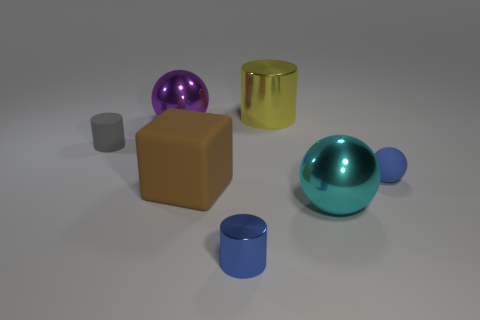What number of other things are there of the same size as the brown matte object?
Provide a short and direct response. 3. How many metal spheres are both behind the big brown thing and in front of the gray matte cylinder?
Offer a very short reply. 0. Is the size of the ball on the right side of the cyan metallic sphere the same as the block that is behind the tiny blue cylinder?
Keep it short and to the point. No. How big is the cylinder in front of the tiny gray rubber cylinder?
Your answer should be compact. Small. What number of things are either things that are in front of the large metal cylinder or things on the right side of the matte block?
Your answer should be compact. 7. Is there anything else of the same color as the rubber cylinder?
Your answer should be very brief. No. Are there an equal number of blue metal objects in front of the small gray matte object and brown blocks that are to the left of the big purple thing?
Your response must be concise. No. Is the number of matte objects on the right side of the rubber cylinder greater than the number of cylinders?
Your answer should be very brief. No. How many things are either metal spheres that are behind the big cyan metal object or large red rubber blocks?
Offer a very short reply. 1. What number of spheres have the same material as the yellow thing?
Give a very brief answer. 2. 